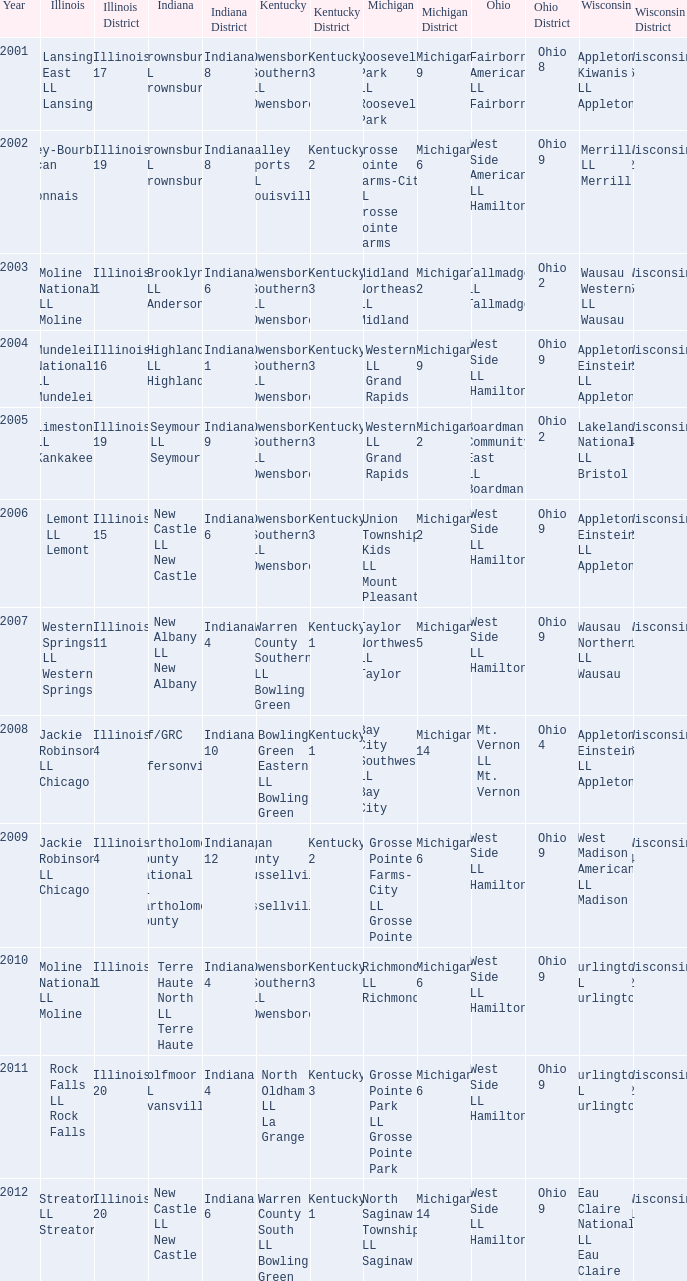What was the little league team from Kentucky when the little league team from Indiana and Wisconsin were Brownsburg LL Brownsburg and Merrill LL Merrill? Valley Sports LL Louisville. 